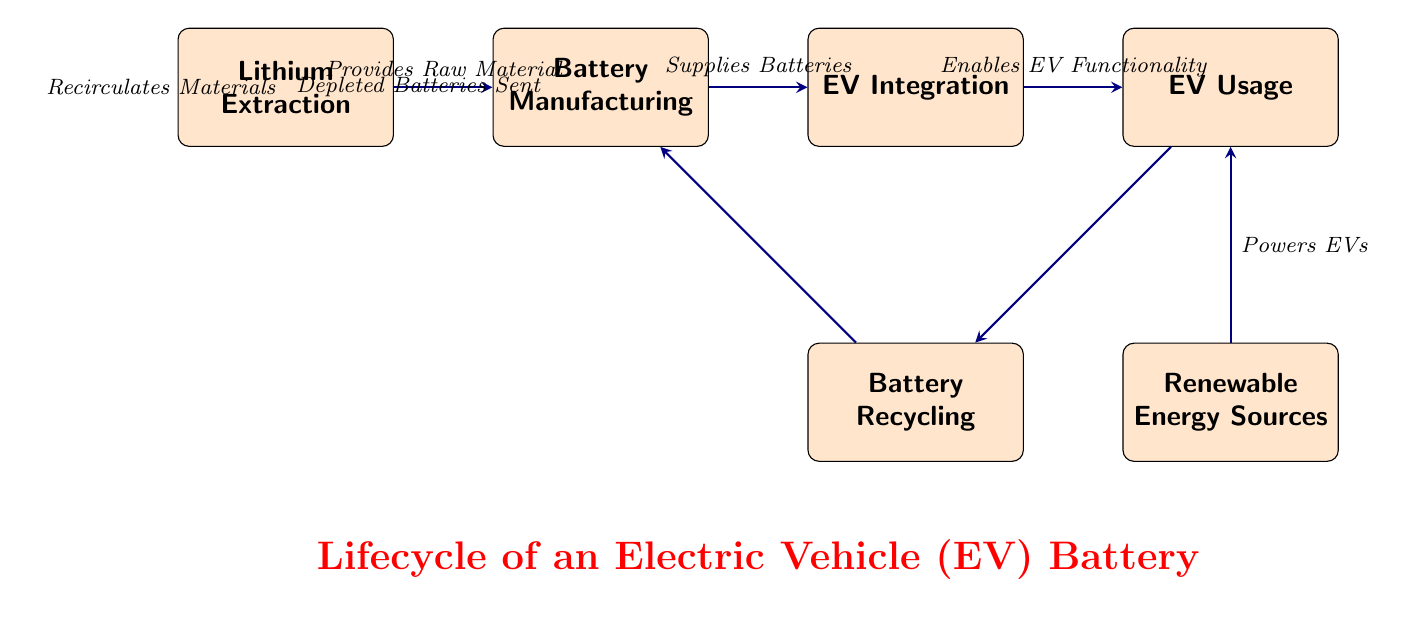What is the first step in the lifecycle of an EV battery? The diagram indicates that the first step in the lifecycle of an EV battery is "Lithium Extraction," as this node is positioned first on the left.
Answer: Lithium Extraction How many main nodes are there in the diagram? The diagram contains six main nodes which include Lithium Extraction, Battery Manufacturing, EV Integration, EV Usage, Battery Recycling, and Renewable Energy Sources.
Answer: 6 What does the "EV Usage" node receive energy from? According to the diagram, the "EV Usage" node receives energy from the "Renewable Energy Sources" node, as indicated by the directional arrow connecting these two nodes.
Answer: Renewable Energy Sources What is done with depleted batteries, according to the diagram? The diagram shows that depleted batteries are sent to the "Battery Recycling" node, which connects from the "EV Usage" node through a directional arrow.
Answer: Battery Recycling What is supplied by the "Battery Manufacturing" node? The "Battery Manufacturing" node supplies "Batteries," as specified by the arrow leading from this node to the "EV Integration" node.
Answer: Batteries How do materials re-enter the lifecycle after battery recycling? After battery recycling, materials are recirculated back to the "Battery Manufacturing" node, as indicated by the directional arrow from "Battery Recycling" to "Battery Manufacturing."
Answer: Recirculates Materials What process enables EV functionality? The process that enables EV functionality is referred to as "Enables EV Functionality," which is noted in the diagram connecting "EV Integration" to "EV Usage."
Answer: Enables EV Functionality Which step involves providing raw material? The step that involves providing raw material is "Lithium Extraction," as this node is positioned first and is directly connected to "Battery Manufacturing" with a directional arrow labeled "Provides Raw Material."
Answer: Provides Raw Material What interaction is indicated between EV usage and renewable energy sources? The interaction indicated is that renewable energy sources power the EVs, as shown by the arrow going from "Renewable Energy Sources" to "EV Usage."
Answer: Powers EVs 